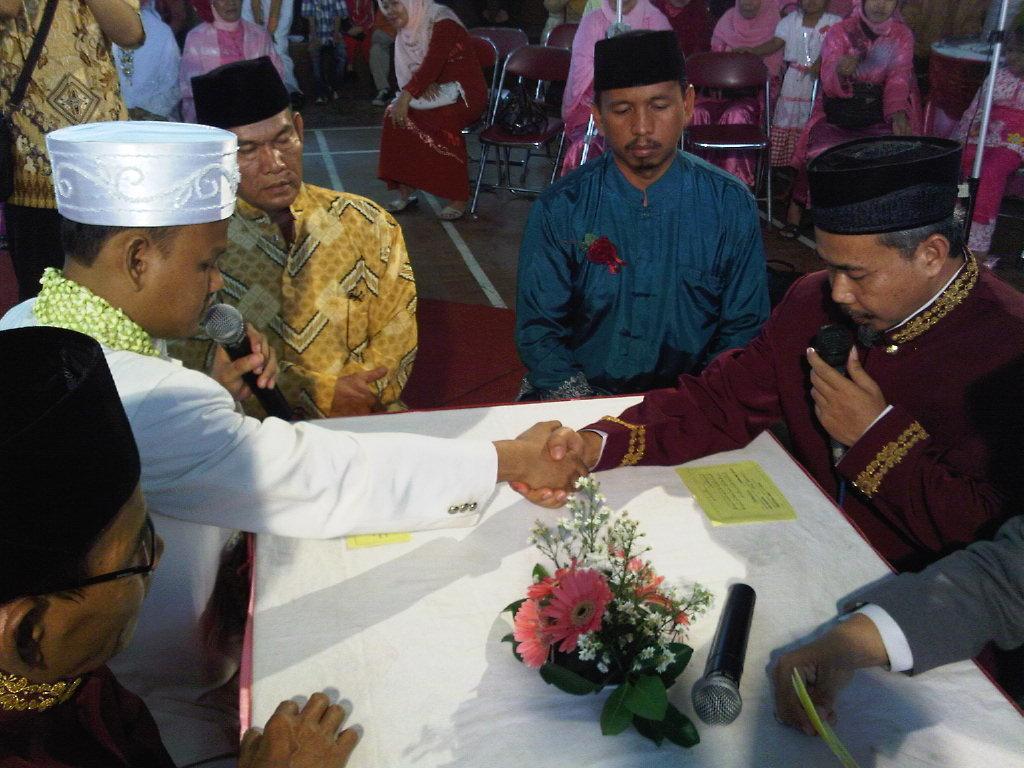How would you summarize this image in a sentence or two? At the bottom of the image there is a table, on the table there is a bouquet and microphone and papers. Surrounding the table few people are sitting and holding microphones. Behind them few people are sitting on chairs. 